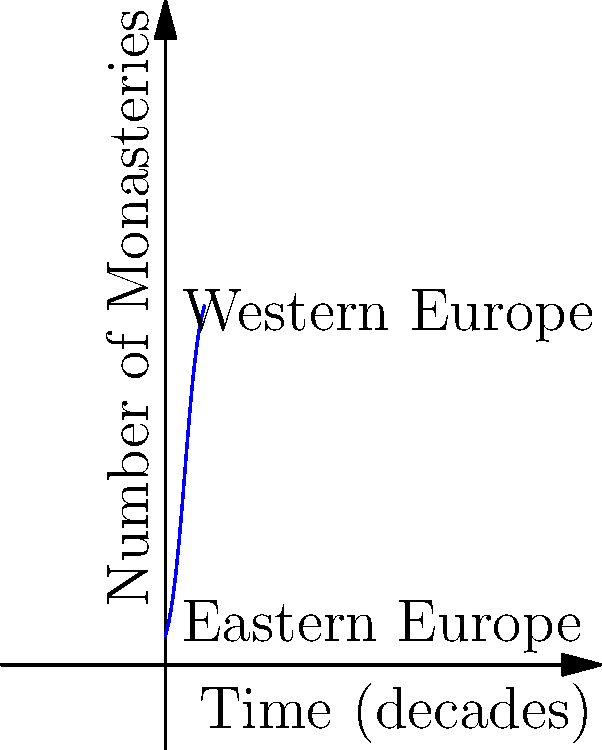The graph represents the growth of monastic orders in Western and Eastern Europe during the 11th century. The function for Western Europe is given by $f(x) = \frac{100}{1+e^{-0.5(x-5)}}$, where $x$ is measured in decades. Calculate the total area under the curve for Western Europe from the beginning to the end of the century (0 to 10 decades). What does this area represent in the context of monastic growth? To solve this problem, we need to integrate the given function over the interval [0, 10]. The steps are as follows:

1) The area under the curve is given by the definite integral:

   $$A = \int_0^{10} \frac{100}{1+e^{-0.5(x-5)}} dx$$

2) This integral doesn't have an elementary antiderivative, so we need to use numerical integration methods.

3) Using the trapezoidal rule with 100 subintervals:

   $$A \approx \frac{10-0}{100} \sum_{i=0}^{99} \frac{1}{2}[f(x_i) + f(x_{i+1})]$$

   where $x_i = i(10/100) = 0.1i$

4) Calculating this sum (which would typically be done by computer) gives:

   $$A \approx 686.47$$

5) The units of this area are (Number of Monasteries) × (Decades)

6) Interpreting this result: The area represents the cumulative presence of monasteries over time. It accounts for both the number of monasteries and how long they existed during the century.

7) A larger area indicates a greater overall monastic presence, considering both the quantity of monasteries and their duration throughout the century.
Answer: 686.47 monastery-decades, representing the cumulative monastic presence in Western Europe during the 11th century. 